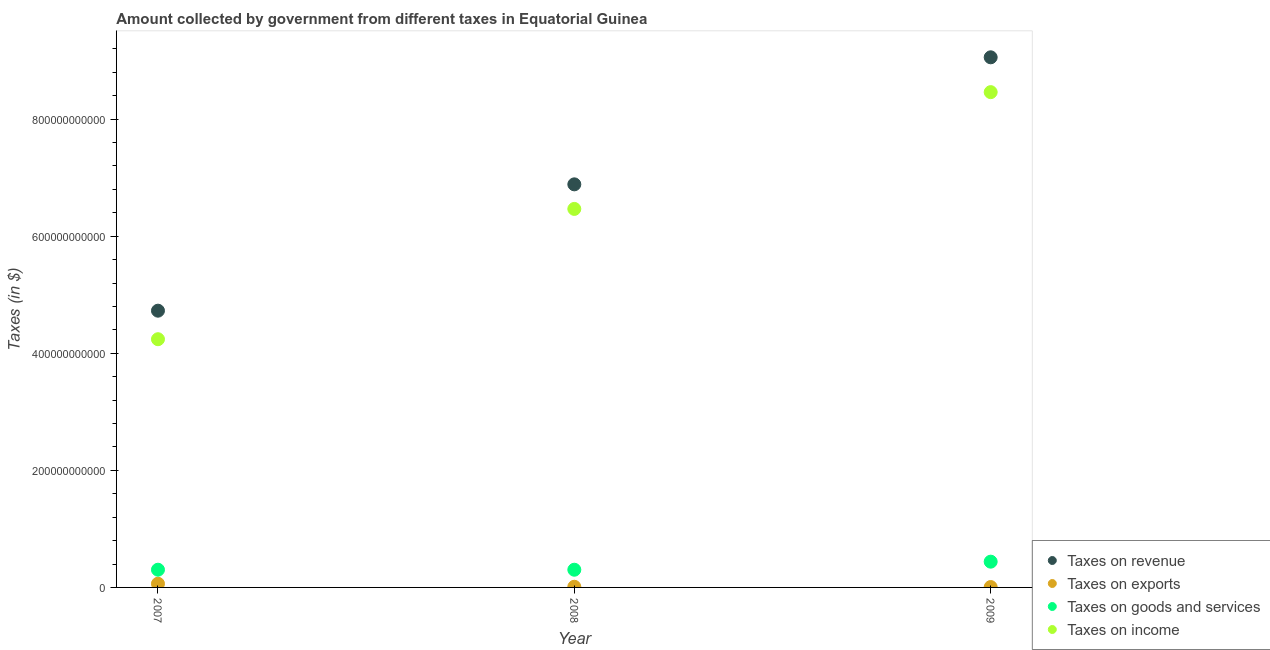How many different coloured dotlines are there?
Offer a very short reply. 4. Is the number of dotlines equal to the number of legend labels?
Provide a short and direct response. Yes. What is the amount collected as tax on goods in 2007?
Provide a succinct answer. 3.03e+1. Across all years, what is the maximum amount collected as tax on revenue?
Your response must be concise. 9.06e+11. Across all years, what is the minimum amount collected as tax on revenue?
Provide a short and direct response. 4.73e+11. In which year was the amount collected as tax on exports maximum?
Offer a very short reply. 2007. In which year was the amount collected as tax on revenue minimum?
Provide a short and direct response. 2007. What is the total amount collected as tax on income in the graph?
Your answer should be compact. 1.92e+12. What is the difference between the amount collected as tax on revenue in 2008 and that in 2009?
Your answer should be compact. -2.17e+11. What is the difference between the amount collected as tax on goods in 2009 and the amount collected as tax on income in 2008?
Your answer should be very brief. -6.03e+11. What is the average amount collected as tax on goods per year?
Make the answer very short. 3.48e+1. In the year 2007, what is the difference between the amount collected as tax on goods and amount collected as tax on exports?
Offer a very short reply. 2.40e+1. In how many years, is the amount collected as tax on exports greater than 680000000000 $?
Your answer should be very brief. 0. What is the ratio of the amount collected as tax on goods in 2007 to that in 2008?
Keep it short and to the point. 1. Is the difference between the amount collected as tax on goods in 2007 and 2009 greater than the difference between the amount collected as tax on revenue in 2007 and 2009?
Provide a succinct answer. Yes. What is the difference between the highest and the second highest amount collected as tax on revenue?
Your answer should be compact. 2.17e+11. What is the difference between the highest and the lowest amount collected as tax on exports?
Your answer should be very brief. 5.66e+09. Does the amount collected as tax on exports monotonically increase over the years?
Give a very brief answer. No. Is the amount collected as tax on income strictly greater than the amount collected as tax on goods over the years?
Your answer should be very brief. Yes. How many dotlines are there?
Your answer should be compact. 4. What is the difference between two consecutive major ticks on the Y-axis?
Give a very brief answer. 2.00e+11. Are the values on the major ticks of Y-axis written in scientific E-notation?
Provide a short and direct response. No. Does the graph contain any zero values?
Ensure brevity in your answer.  No. Does the graph contain grids?
Provide a short and direct response. No. What is the title of the graph?
Ensure brevity in your answer.  Amount collected by government from different taxes in Equatorial Guinea. What is the label or title of the X-axis?
Provide a short and direct response. Year. What is the label or title of the Y-axis?
Your answer should be very brief. Taxes (in $). What is the Taxes (in $) in Taxes on revenue in 2007?
Your answer should be compact. 4.73e+11. What is the Taxes (in $) in Taxes on exports in 2007?
Your response must be concise. 6.32e+09. What is the Taxes (in $) in Taxes on goods and services in 2007?
Keep it short and to the point. 3.03e+1. What is the Taxes (in $) of Taxes on income in 2007?
Your response must be concise. 4.24e+11. What is the Taxes (in $) of Taxes on revenue in 2008?
Your response must be concise. 6.89e+11. What is the Taxes (in $) of Taxes on exports in 2008?
Keep it short and to the point. 1.14e+09. What is the Taxes (in $) in Taxes on goods and services in 2008?
Provide a succinct answer. 3.03e+1. What is the Taxes (in $) in Taxes on income in 2008?
Provide a succinct answer. 6.47e+11. What is the Taxes (in $) in Taxes on revenue in 2009?
Provide a short and direct response. 9.06e+11. What is the Taxes (in $) of Taxes on exports in 2009?
Your answer should be very brief. 6.58e+08. What is the Taxes (in $) in Taxes on goods and services in 2009?
Your answer should be very brief. 4.40e+1. What is the Taxes (in $) in Taxes on income in 2009?
Give a very brief answer. 8.46e+11. Across all years, what is the maximum Taxes (in $) of Taxes on revenue?
Keep it short and to the point. 9.06e+11. Across all years, what is the maximum Taxes (in $) in Taxes on exports?
Ensure brevity in your answer.  6.32e+09. Across all years, what is the maximum Taxes (in $) in Taxes on goods and services?
Offer a very short reply. 4.40e+1. Across all years, what is the maximum Taxes (in $) in Taxes on income?
Make the answer very short. 8.46e+11. Across all years, what is the minimum Taxes (in $) in Taxes on revenue?
Offer a very short reply. 4.73e+11. Across all years, what is the minimum Taxes (in $) in Taxes on exports?
Your response must be concise. 6.58e+08. Across all years, what is the minimum Taxes (in $) in Taxes on goods and services?
Ensure brevity in your answer.  3.03e+1. Across all years, what is the minimum Taxes (in $) of Taxes on income?
Provide a succinct answer. 4.24e+11. What is the total Taxes (in $) in Taxes on revenue in the graph?
Offer a very short reply. 2.07e+12. What is the total Taxes (in $) in Taxes on exports in the graph?
Ensure brevity in your answer.  8.11e+09. What is the total Taxes (in $) of Taxes on goods and services in the graph?
Your answer should be very brief. 1.05e+11. What is the total Taxes (in $) of Taxes on income in the graph?
Ensure brevity in your answer.  1.92e+12. What is the difference between the Taxes (in $) of Taxes on revenue in 2007 and that in 2008?
Ensure brevity in your answer.  -2.16e+11. What is the difference between the Taxes (in $) of Taxes on exports in 2007 and that in 2008?
Offer a very short reply. 5.17e+09. What is the difference between the Taxes (in $) of Taxes on goods and services in 2007 and that in 2008?
Ensure brevity in your answer.  1.60e+07. What is the difference between the Taxes (in $) in Taxes on income in 2007 and that in 2008?
Your answer should be very brief. -2.23e+11. What is the difference between the Taxes (in $) in Taxes on revenue in 2007 and that in 2009?
Your answer should be very brief. -4.33e+11. What is the difference between the Taxes (in $) in Taxes on exports in 2007 and that in 2009?
Your response must be concise. 5.66e+09. What is the difference between the Taxes (in $) of Taxes on goods and services in 2007 and that in 2009?
Offer a very short reply. -1.37e+1. What is the difference between the Taxes (in $) of Taxes on income in 2007 and that in 2009?
Give a very brief answer. -4.22e+11. What is the difference between the Taxes (in $) of Taxes on revenue in 2008 and that in 2009?
Keep it short and to the point. -2.17e+11. What is the difference between the Taxes (in $) in Taxes on exports in 2008 and that in 2009?
Offer a terse response. 4.83e+08. What is the difference between the Taxes (in $) in Taxes on goods and services in 2008 and that in 2009?
Ensure brevity in your answer.  -1.37e+1. What is the difference between the Taxes (in $) in Taxes on income in 2008 and that in 2009?
Ensure brevity in your answer.  -1.99e+11. What is the difference between the Taxes (in $) of Taxes on revenue in 2007 and the Taxes (in $) of Taxes on exports in 2008?
Offer a terse response. 4.72e+11. What is the difference between the Taxes (in $) of Taxes on revenue in 2007 and the Taxes (in $) of Taxes on goods and services in 2008?
Keep it short and to the point. 4.43e+11. What is the difference between the Taxes (in $) of Taxes on revenue in 2007 and the Taxes (in $) of Taxes on income in 2008?
Your answer should be compact. -1.74e+11. What is the difference between the Taxes (in $) in Taxes on exports in 2007 and the Taxes (in $) in Taxes on goods and services in 2008?
Offer a terse response. -2.39e+1. What is the difference between the Taxes (in $) in Taxes on exports in 2007 and the Taxes (in $) in Taxes on income in 2008?
Give a very brief answer. -6.40e+11. What is the difference between the Taxes (in $) in Taxes on goods and services in 2007 and the Taxes (in $) in Taxes on income in 2008?
Offer a very short reply. -6.16e+11. What is the difference between the Taxes (in $) in Taxes on revenue in 2007 and the Taxes (in $) in Taxes on exports in 2009?
Your answer should be compact. 4.72e+11. What is the difference between the Taxes (in $) in Taxes on revenue in 2007 and the Taxes (in $) in Taxes on goods and services in 2009?
Offer a very short reply. 4.29e+11. What is the difference between the Taxes (in $) of Taxes on revenue in 2007 and the Taxes (in $) of Taxes on income in 2009?
Make the answer very short. -3.73e+11. What is the difference between the Taxes (in $) of Taxes on exports in 2007 and the Taxes (in $) of Taxes on goods and services in 2009?
Offer a very short reply. -3.77e+1. What is the difference between the Taxes (in $) in Taxes on exports in 2007 and the Taxes (in $) in Taxes on income in 2009?
Ensure brevity in your answer.  -8.40e+11. What is the difference between the Taxes (in $) of Taxes on goods and services in 2007 and the Taxes (in $) of Taxes on income in 2009?
Make the answer very short. -8.16e+11. What is the difference between the Taxes (in $) in Taxes on revenue in 2008 and the Taxes (in $) in Taxes on exports in 2009?
Provide a short and direct response. 6.88e+11. What is the difference between the Taxes (in $) of Taxes on revenue in 2008 and the Taxes (in $) of Taxes on goods and services in 2009?
Offer a very short reply. 6.45e+11. What is the difference between the Taxes (in $) of Taxes on revenue in 2008 and the Taxes (in $) of Taxes on income in 2009?
Provide a short and direct response. -1.58e+11. What is the difference between the Taxes (in $) in Taxes on exports in 2008 and the Taxes (in $) in Taxes on goods and services in 2009?
Make the answer very short. -4.29e+1. What is the difference between the Taxes (in $) in Taxes on exports in 2008 and the Taxes (in $) in Taxes on income in 2009?
Ensure brevity in your answer.  -8.45e+11. What is the difference between the Taxes (in $) in Taxes on goods and services in 2008 and the Taxes (in $) in Taxes on income in 2009?
Make the answer very short. -8.16e+11. What is the average Taxes (in $) of Taxes on revenue per year?
Ensure brevity in your answer.  6.89e+11. What is the average Taxes (in $) of Taxes on exports per year?
Offer a terse response. 2.70e+09. What is the average Taxes (in $) in Taxes on goods and services per year?
Provide a short and direct response. 3.48e+1. What is the average Taxes (in $) in Taxes on income per year?
Your answer should be compact. 6.39e+11. In the year 2007, what is the difference between the Taxes (in $) of Taxes on revenue and Taxes (in $) of Taxes on exports?
Offer a terse response. 4.66e+11. In the year 2007, what is the difference between the Taxes (in $) of Taxes on revenue and Taxes (in $) of Taxes on goods and services?
Offer a very short reply. 4.43e+11. In the year 2007, what is the difference between the Taxes (in $) of Taxes on revenue and Taxes (in $) of Taxes on income?
Give a very brief answer. 4.87e+1. In the year 2007, what is the difference between the Taxes (in $) in Taxes on exports and Taxes (in $) in Taxes on goods and services?
Keep it short and to the point. -2.40e+1. In the year 2007, what is the difference between the Taxes (in $) of Taxes on exports and Taxes (in $) of Taxes on income?
Give a very brief answer. -4.18e+11. In the year 2007, what is the difference between the Taxes (in $) of Taxes on goods and services and Taxes (in $) of Taxes on income?
Give a very brief answer. -3.94e+11. In the year 2008, what is the difference between the Taxes (in $) of Taxes on revenue and Taxes (in $) of Taxes on exports?
Provide a short and direct response. 6.87e+11. In the year 2008, what is the difference between the Taxes (in $) of Taxes on revenue and Taxes (in $) of Taxes on goods and services?
Provide a succinct answer. 6.58e+11. In the year 2008, what is the difference between the Taxes (in $) of Taxes on revenue and Taxes (in $) of Taxes on income?
Offer a terse response. 4.20e+1. In the year 2008, what is the difference between the Taxes (in $) in Taxes on exports and Taxes (in $) in Taxes on goods and services?
Offer a very short reply. -2.91e+1. In the year 2008, what is the difference between the Taxes (in $) of Taxes on exports and Taxes (in $) of Taxes on income?
Offer a very short reply. -6.46e+11. In the year 2008, what is the difference between the Taxes (in $) in Taxes on goods and services and Taxes (in $) in Taxes on income?
Offer a very short reply. -6.16e+11. In the year 2009, what is the difference between the Taxes (in $) in Taxes on revenue and Taxes (in $) in Taxes on exports?
Your response must be concise. 9.05e+11. In the year 2009, what is the difference between the Taxes (in $) of Taxes on revenue and Taxes (in $) of Taxes on goods and services?
Give a very brief answer. 8.62e+11. In the year 2009, what is the difference between the Taxes (in $) in Taxes on revenue and Taxes (in $) in Taxes on income?
Your answer should be compact. 5.95e+1. In the year 2009, what is the difference between the Taxes (in $) in Taxes on exports and Taxes (in $) in Taxes on goods and services?
Provide a succinct answer. -4.33e+1. In the year 2009, what is the difference between the Taxes (in $) in Taxes on exports and Taxes (in $) in Taxes on income?
Keep it short and to the point. -8.45e+11. In the year 2009, what is the difference between the Taxes (in $) of Taxes on goods and services and Taxes (in $) of Taxes on income?
Give a very brief answer. -8.02e+11. What is the ratio of the Taxes (in $) of Taxes on revenue in 2007 to that in 2008?
Give a very brief answer. 0.69. What is the ratio of the Taxes (in $) of Taxes on exports in 2007 to that in 2008?
Your answer should be compact. 5.53. What is the ratio of the Taxes (in $) of Taxes on income in 2007 to that in 2008?
Offer a terse response. 0.66. What is the ratio of the Taxes (in $) in Taxes on revenue in 2007 to that in 2009?
Make the answer very short. 0.52. What is the ratio of the Taxes (in $) in Taxes on exports in 2007 to that in 2009?
Offer a terse response. 9.6. What is the ratio of the Taxes (in $) of Taxes on goods and services in 2007 to that in 2009?
Give a very brief answer. 0.69. What is the ratio of the Taxes (in $) in Taxes on income in 2007 to that in 2009?
Offer a terse response. 0.5. What is the ratio of the Taxes (in $) of Taxes on revenue in 2008 to that in 2009?
Keep it short and to the point. 0.76. What is the ratio of the Taxes (in $) of Taxes on exports in 2008 to that in 2009?
Keep it short and to the point. 1.73. What is the ratio of the Taxes (in $) in Taxes on goods and services in 2008 to that in 2009?
Make the answer very short. 0.69. What is the ratio of the Taxes (in $) of Taxes on income in 2008 to that in 2009?
Ensure brevity in your answer.  0.76. What is the difference between the highest and the second highest Taxes (in $) in Taxes on revenue?
Your answer should be compact. 2.17e+11. What is the difference between the highest and the second highest Taxes (in $) of Taxes on exports?
Your answer should be compact. 5.17e+09. What is the difference between the highest and the second highest Taxes (in $) of Taxes on goods and services?
Provide a succinct answer. 1.37e+1. What is the difference between the highest and the second highest Taxes (in $) in Taxes on income?
Your response must be concise. 1.99e+11. What is the difference between the highest and the lowest Taxes (in $) in Taxes on revenue?
Make the answer very short. 4.33e+11. What is the difference between the highest and the lowest Taxes (in $) of Taxes on exports?
Give a very brief answer. 5.66e+09. What is the difference between the highest and the lowest Taxes (in $) of Taxes on goods and services?
Your answer should be very brief. 1.37e+1. What is the difference between the highest and the lowest Taxes (in $) in Taxes on income?
Ensure brevity in your answer.  4.22e+11. 